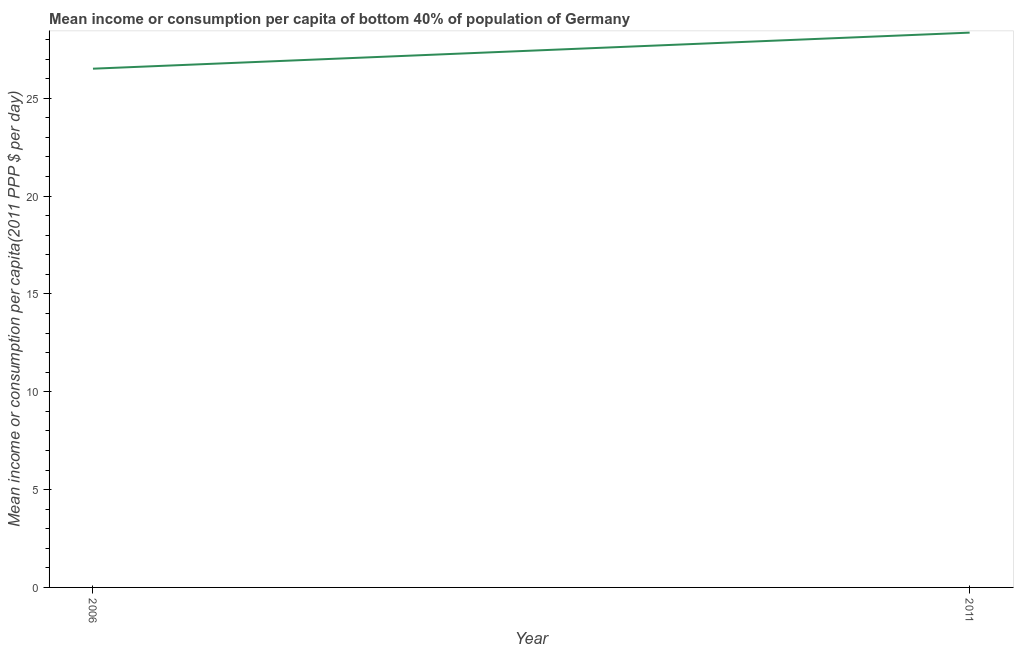What is the mean income or consumption in 2006?
Ensure brevity in your answer.  26.51. Across all years, what is the maximum mean income or consumption?
Your response must be concise. 28.35. Across all years, what is the minimum mean income or consumption?
Ensure brevity in your answer.  26.51. What is the sum of the mean income or consumption?
Your answer should be compact. 54.86. What is the difference between the mean income or consumption in 2006 and 2011?
Your answer should be compact. -1.84. What is the average mean income or consumption per year?
Your answer should be compact. 27.43. What is the median mean income or consumption?
Your response must be concise. 27.43. In how many years, is the mean income or consumption greater than 12 $?
Give a very brief answer. 2. Do a majority of the years between 2006 and 2011 (inclusive) have mean income or consumption greater than 14 $?
Make the answer very short. Yes. What is the ratio of the mean income or consumption in 2006 to that in 2011?
Your answer should be very brief. 0.93. What is the difference between two consecutive major ticks on the Y-axis?
Provide a short and direct response. 5. Does the graph contain any zero values?
Provide a succinct answer. No. Does the graph contain grids?
Offer a terse response. No. What is the title of the graph?
Provide a short and direct response. Mean income or consumption per capita of bottom 40% of population of Germany. What is the label or title of the Y-axis?
Your answer should be compact. Mean income or consumption per capita(2011 PPP $ per day). What is the Mean income or consumption per capita(2011 PPP $ per day) in 2006?
Provide a succinct answer. 26.51. What is the Mean income or consumption per capita(2011 PPP $ per day) of 2011?
Ensure brevity in your answer.  28.35. What is the difference between the Mean income or consumption per capita(2011 PPP $ per day) in 2006 and 2011?
Offer a terse response. -1.84. What is the ratio of the Mean income or consumption per capita(2011 PPP $ per day) in 2006 to that in 2011?
Ensure brevity in your answer.  0.94. 